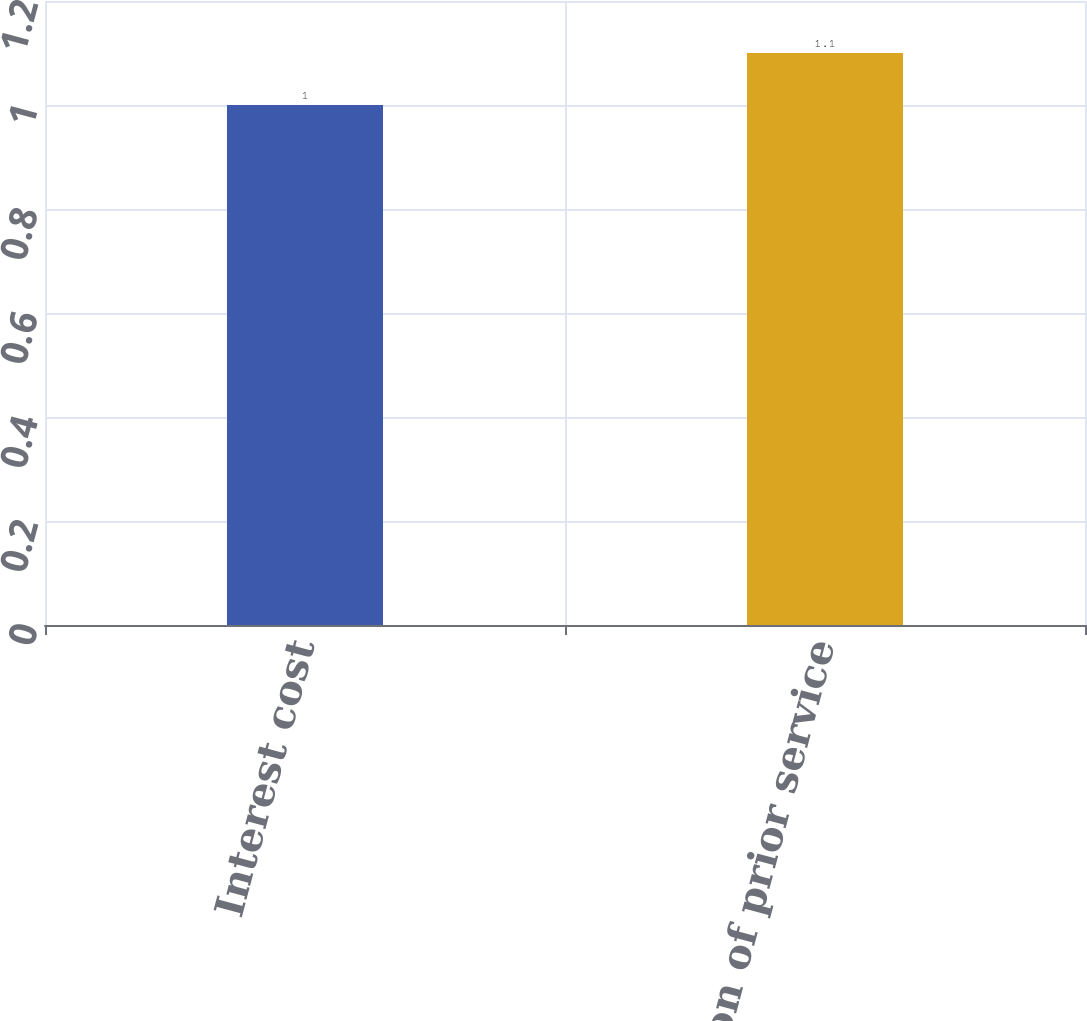Convert chart. <chart><loc_0><loc_0><loc_500><loc_500><bar_chart><fcel>Interest cost<fcel>Amortization of prior service<nl><fcel>1<fcel>1.1<nl></chart> 